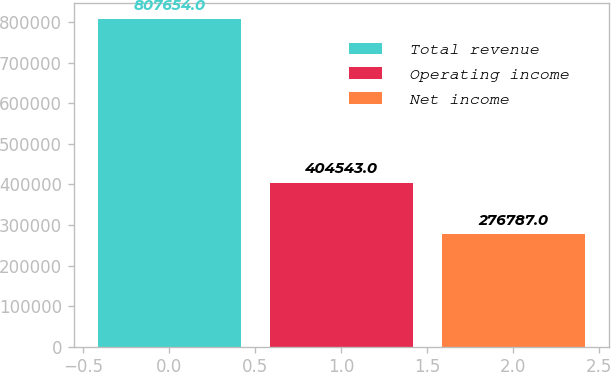<chart> <loc_0><loc_0><loc_500><loc_500><bar_chart><fcel>Total revenue<fcel>Operating income<fcel>Net income<nl><fcel>807654<fcel>404543<fcel>276787<nl></chart> 